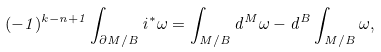<formula> <loc_0><loc_0><loc_500><loc_500>( - 1 ) ^ { k - n + 1 } \int _ { \partial M / B } i ^ { * } \omega = \int _ { M / B } d ^ { M } \omega - d ^ { B } \int _ { M / B } \omega ,</formula> 